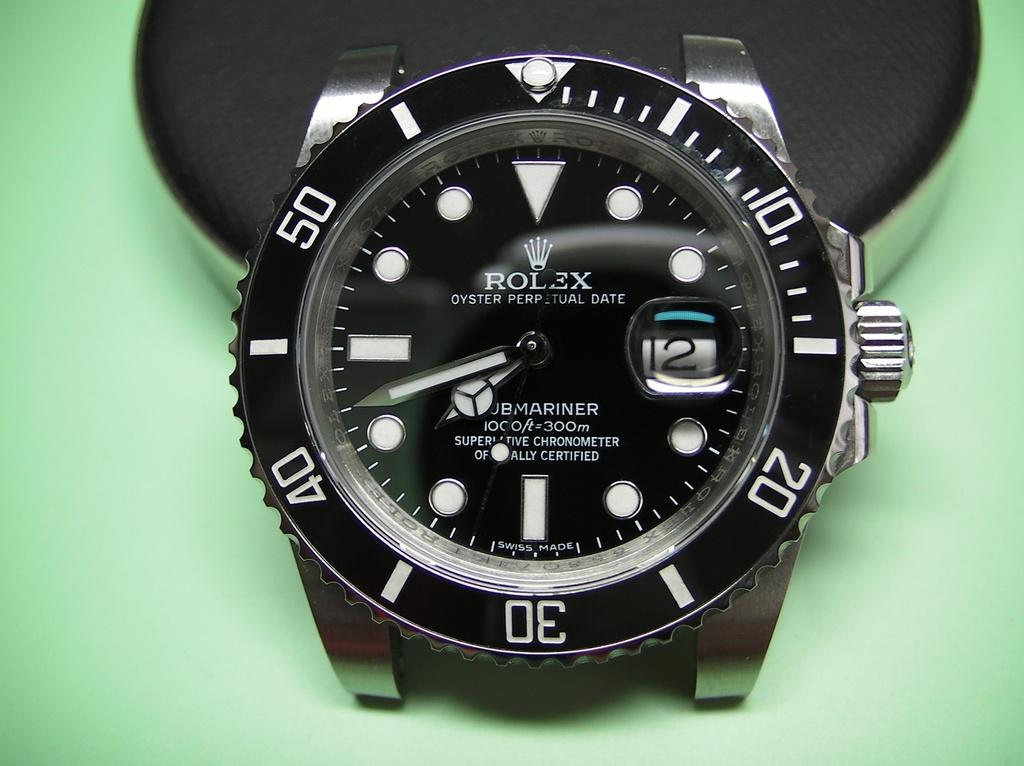<image>
Provide a brief description of the given image. A black watch that says Rolex on the face is on a mint green background. 